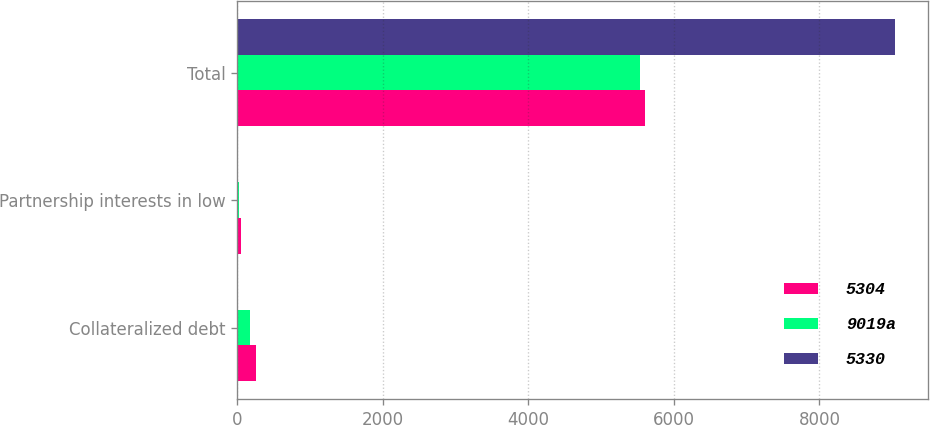<chart> <loc_0><loc_0><loc_500><loc_500><stacked_bar_chart><ecel><fcel>Collateralized debt<fcel>Partnership interests in low<fcel>Total<nl><fcel>5304<fcel>255<fcel>50<fcel>5609<nl><fcel>9019a<fcel>177<fcel>34<fcel>5541<nl><fcel>5330<fcel>6<fcel>8<fcel>9033<nl></chart> 